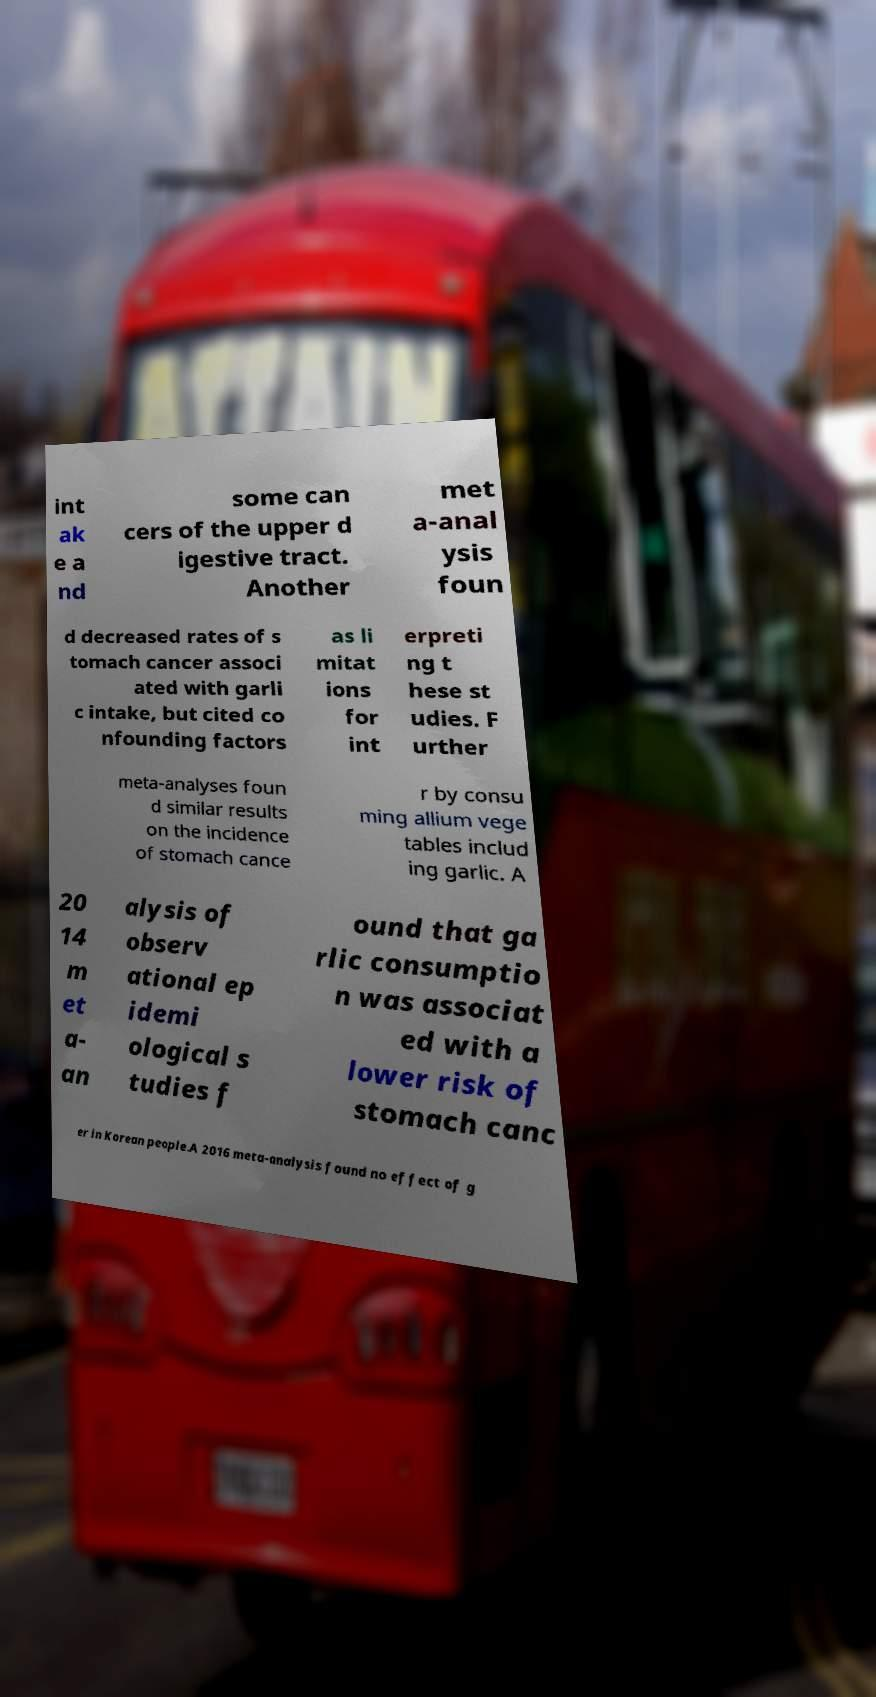Please identify and transcribe the text found in this image. int ak e a nd some can cers of the upper d igestive tract. Another met a-anal ysis foun d decreased rates of s tomach cancer associ ated with garli c intake, but cited co nfounding factors as li mitat ions for int erpreti ng t hese st udies. F urther meta-analyses foun d similar results on the incidence of stomach cance r by consu ming allium vege tables includ ing garlic. A 20 14 m et a- an alysis of observ ational ep idemi ological s tudies f ound that ga rlic consumptio n was associat ed with a lower risk of stomach canc er in Korean people.A 2016 meta-analysis found no effect of g 